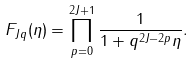<formula> <loc_0><loc_0><loc_500><loc_500>F _ { J q } ( \eta ) = \prod _ { p = 0 } ^ { 2 J + 1 } \frac { 1 } { 1 + q ^ { 2 J - 2 p } \eta } .</formula> 